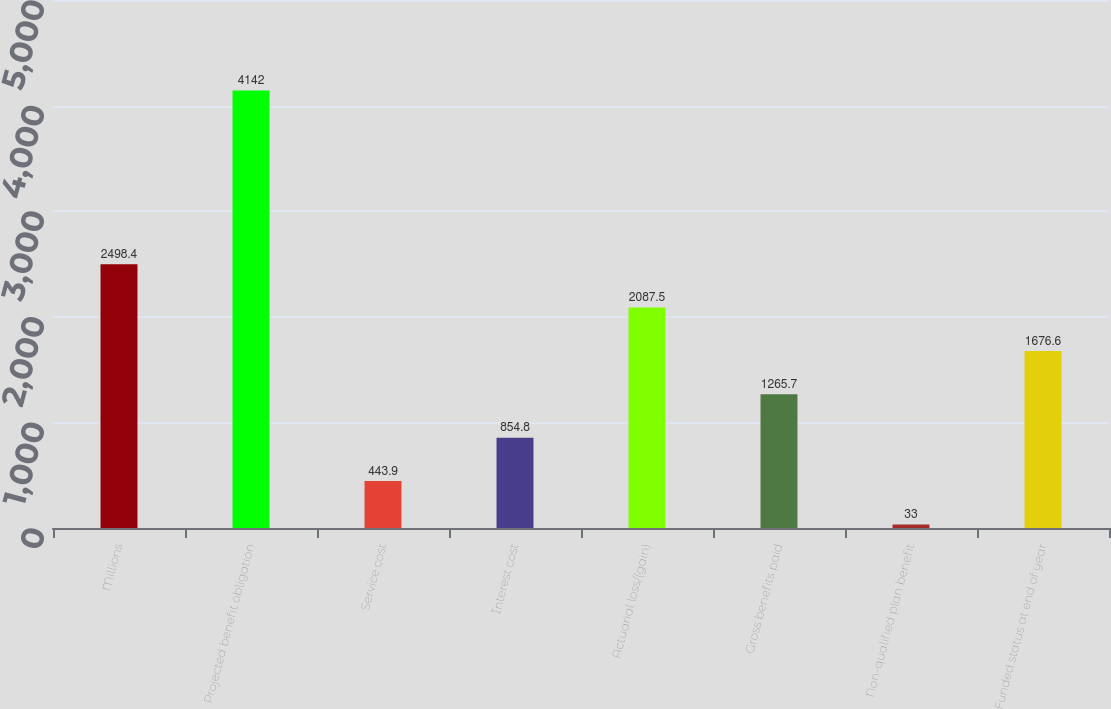Convert chart to OTSL. <chart><loc_0><loc_0><loc_500><loc_500><bar_chart><fcel>Millions<fcel>Projected benefit obligation<fcel>Service cost<fcel>Interest cost<fcel>Actuarial loss/(gain)<fcel>Gross benefits paid<fcel>Non-qualified plan benefit<fcel>Funded status at end of year<nl><fcel>2498.4<fcel>4142<fcel>443.9<fcel>854.8<fcel>2087.5<fcel>1265.7<fcel>33<fcel>1676.6<nl></chart> 